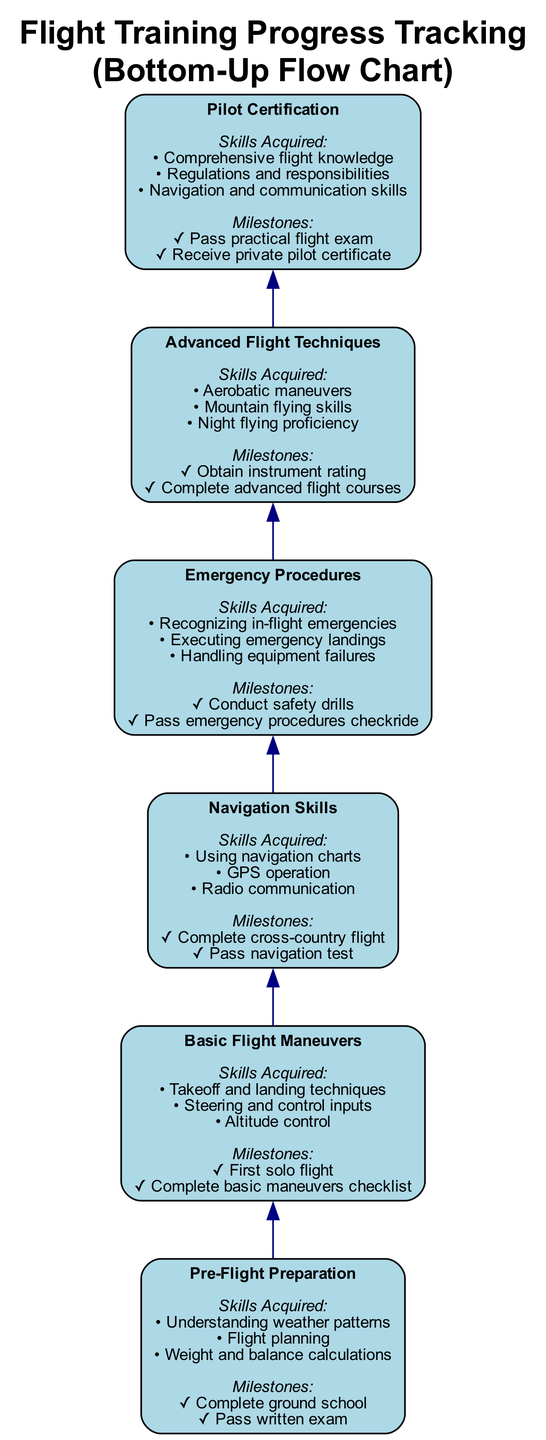What is the first milestone in the flight training process? The diagram starts with "Pre-Flight Preparation", which includes milestones. The first milestone listed is "Complete ground school".
Answer: Complete ground school How many skills are acquired in the "Emergency Procedures" stage? The "Emergency Procedures" node lists three acquired skills: recognizing in-flight emergencies, executing emergency landings, and handling equipment failures.
Answer: Three What is the last skill acquired before achieving "Pilot Certification"? The "Pilot Certification" node details skills acquired, the last of which is "Navigation and communication skills".
Answer: Navigation and communication skills Which two elements directly lead to the "Pilot Certification" stage? The "Pilot Certification" is connected from "Advanced Flight Techniques" and "Emergency Procedures", which directly precede it in the flowchart.
Answer: Advanced Flight Techniques and Emergency Procedures What milestone is associated with the "Basic Flight Maneuvers" stage? In the "Basic Flight Maneuvers" node, the milestones listed are "First solo flight" and "Complete basic maneuvers checklist". The first milestone is what we are looking for.
Answer: First solo flight What skill is associated with the "Navigation Skills" milestone? The "Navigation Skills" node lists three skills acquired, including "Using navigation charts", which is directly related to the navigation aspect of flying.
Answer: Using navigation charts How many nodes are in the diagram? The diagram has six nodes, each representing different training stages from "Pre-Flight Preparation" to "Pilot Certification".
Answer: Six What is the penultimate milestone before obtaining the instrument rating? The "Advanced Flight Techniques" stage lists two milestones, the first being "Obtain instrument rating". Therefore, the penultimate milestone is the one that occurs before it, which is "Complete advanced flight courses".
Answer: Complete advanced flight courses Which skill is unique to the "Advanced Flight Techniques" compared to the other stages? The "Advanced Flight Techniques" stage encompasses skills like "Aerobatic maneuvers", making this skill unique as it is not mentioned in any other node.
Answer: Aerobatic maneuvers 